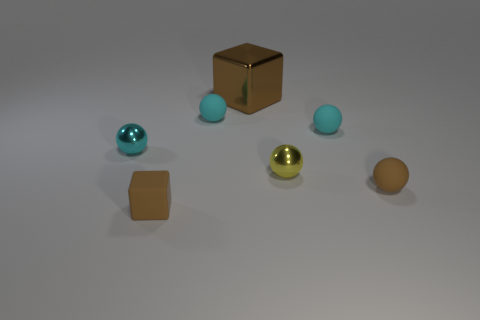Is the material of the large cube that is behind the small brown matte block the same as the small brown object that is in front of the brown sphere?
Provide a short and direct response. No. Is there a cyan rubber object on the right side of the small cyan matte ball to the left of the metal block?
Provide a short and direct response. Yes. What is the color of the cube that is the same material as the small brown ball?
Your answer should be very brief. Brown. Is the number of yellow metal balls greater than the number of red cubes?
Keep it short and to the point. Yes. What number of objects are either cyan spheres left of the yellow object or gray shiny blocks?
Your answer should be very brief. 2. Is there a green matte sphere of the same size as the cyan metal ball?
Offer a very short reply. No. Is the number of cyan metal spheres less than the number of purple metal spheres?
Ensure brevity in your answer.  No. How many balls are brown things or small metallic things?
Provide a succinct answer. 3. What number of small objects have the same color as the large block?
Provide a succinct answer. 2. What size is the shiny object that is right of the matte cube and behind the tiny yellow sphere?
Keep it short and to the point. Large. 